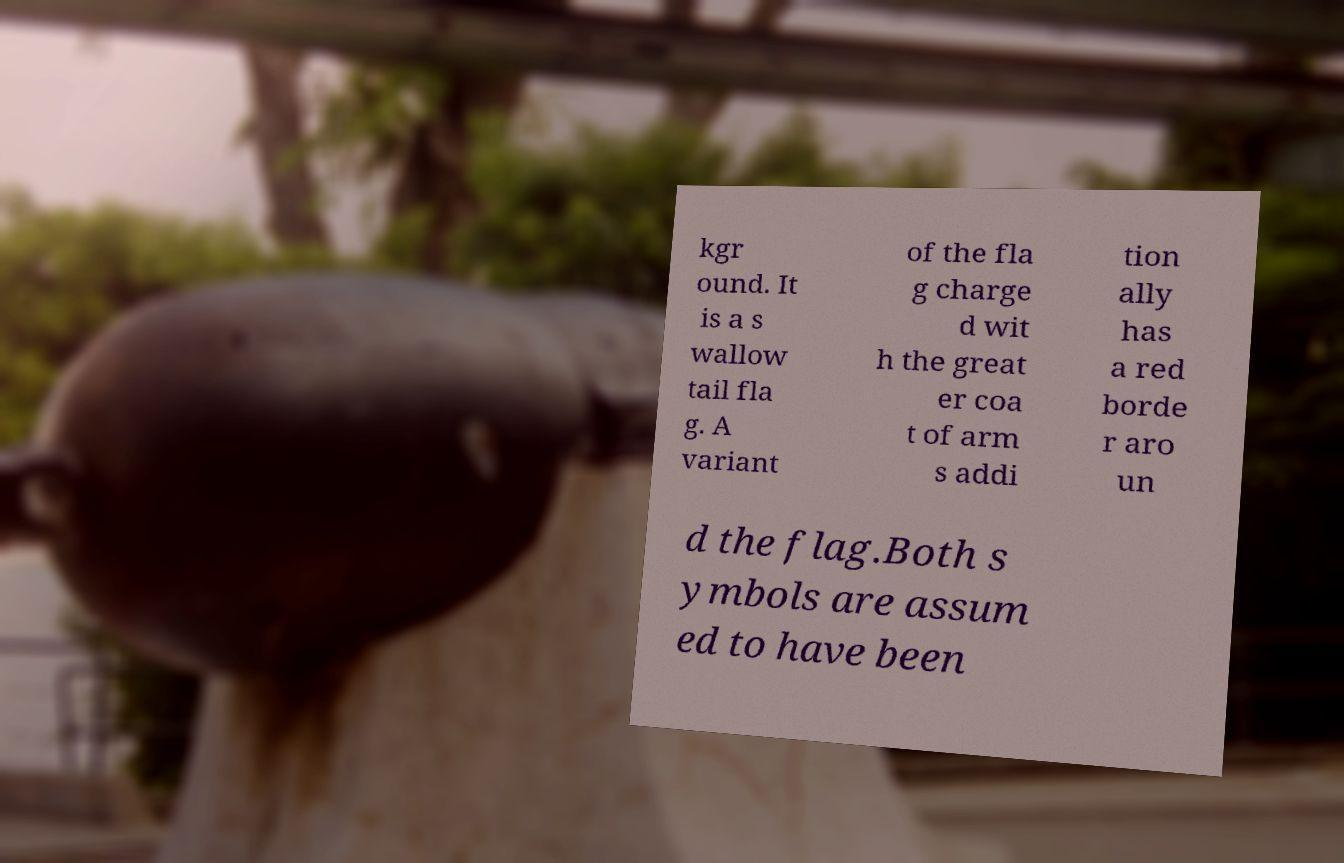For documentation purposes, I need the text within this image transcribed. Could you provide that? kgr ound. It is a s wallow tail fla g. A variant of the fla g charge d wit h the great er coa t of arm s addi tion ally has a red borde r aro un d the flag.Both s ymbols are assum ed to have been 